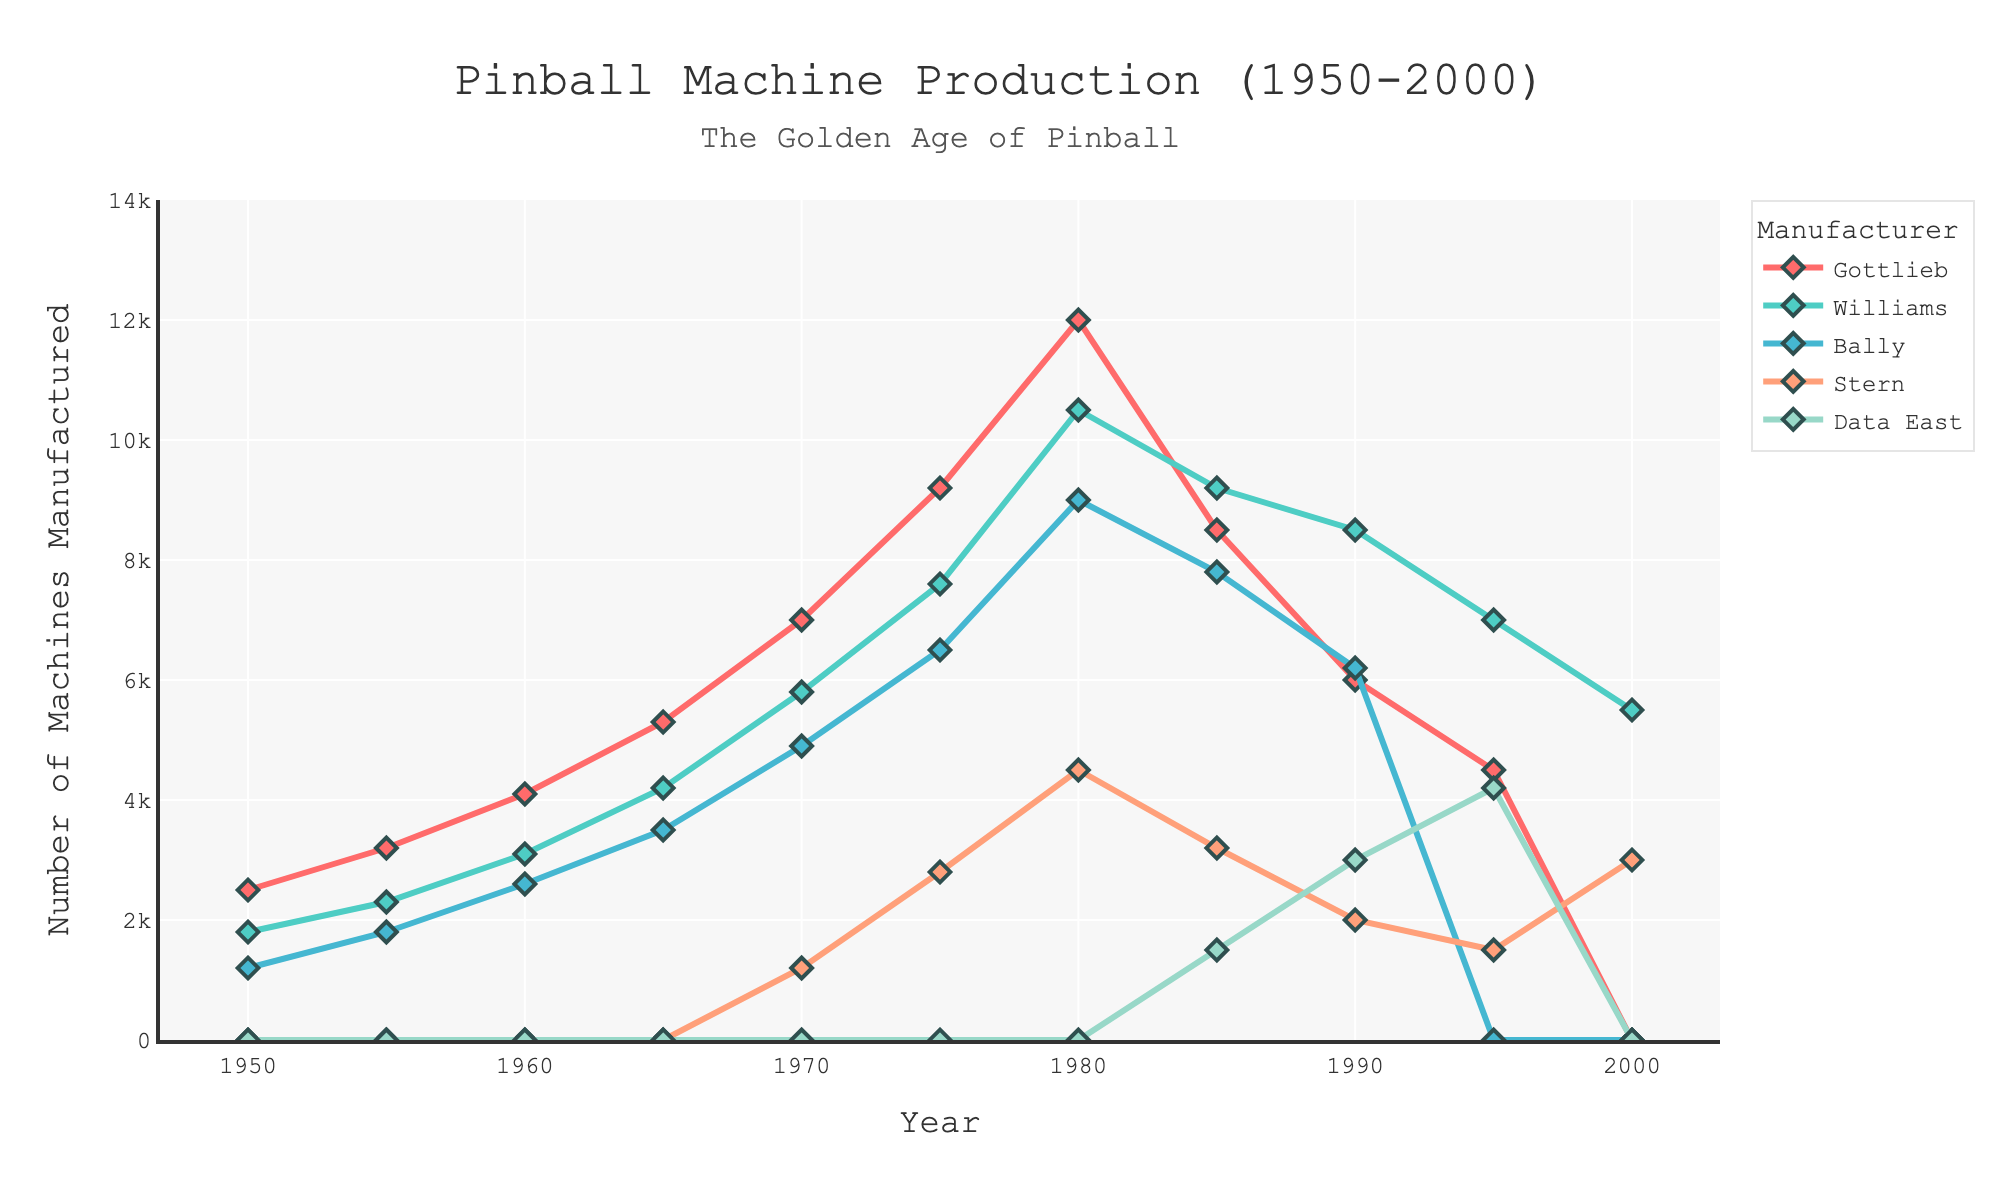What's the highest number of pinball machines Gottlieb manufactured in a year? To find the highest number, look at the highest peak in the Gottlieb line on the chart. Gottlieb's peak production is around 1980.
Answer: 12000 In which year did Williams surpass Gottlieb in production for the first time? Look for the first point on the chart where the Williams line is above the Gottlieb line. It occurs around 1990.
Answer: 1990 Which manufacturer stopped production after 1995? Examine the lines on the chart and notice that Bally does not have any data points beyond 1995.
Answer: Bally In 1975, what is the total number of pinball machines manufactured by Gottlieb and Williams? Sum the values of Gottlieb and Williams for 1975. Gottlieb produced 9200 units and Williams produced 7600 units. Summing these gives 9200 + 7600 = 16800.
Answer: 16800 Compare the number of machines manufactured by Stern in 1980 and 2000. Identify the data points for Stern in 1980 and 2000 from the chart. In 1980, Stern manufactured 4500 machines, and in 2000, 3000 machines.
Answer: Stern's 1980 production is greater than its 2000 production What year did Data East first start manufacturing? Look for the first non-zero data point in the Data East line on the chart. This occurs around 1985.
Answer: 1985 How many manufacturers were producing pinball machines in 1950? Identify the distinct lines on the chart for 1950 with non-zero values. Gottlieb, Williams, and Bally were in production.
Answer: Three During the peak production year of Williams, how did its production compare to the other manufacturers? Find the peak in the Williams line (10500 in 1980) and compare it to the values of other lines for the same year. Gottlieb produced 12000, Bally 9000, and Stern 4500 in 1980.
Answer: Williams was second, behind Gottlieb in 1980 Which manufacturer showed a consistently increasing trend until 1980? Look for a line that increases without dips from 1950 to 1980. The lines for Gottlieb, Williams, and Bally all show an increasing trend, but Gottlieb has no dips.
Answer: Gottlieb What was the difference between the number of machines produced by Gottlieb and Williams in 1990? Subtract the number of machines produced by Williams from those produced by Gottlieb in 1990. Gottlieb produced 6000 and Williams produced 8500. So, 8500 - 6000 = 2500.
Answer: 2500 